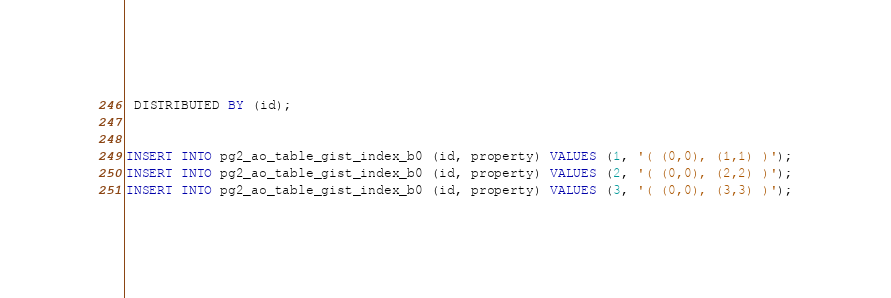<code> <loc_0><loc_0><loc_500><loc_500><_SQL_> DISTRIBUTED BY (id);


INSERT INTO pg2_ao_table_gist_index_b0 (id, property) VALUES (1, '( (0,0), (1,1) )');
INSERT INTO pg2_ao_table_gist_index_b0 (id, property) VALUES (2, '( (0,0), (2,2) )');
INSERT INTO pg2_ao_table_gist_index_b0 (id, property) VALUES (3, '( (0,0), (3,3) )');</code> 